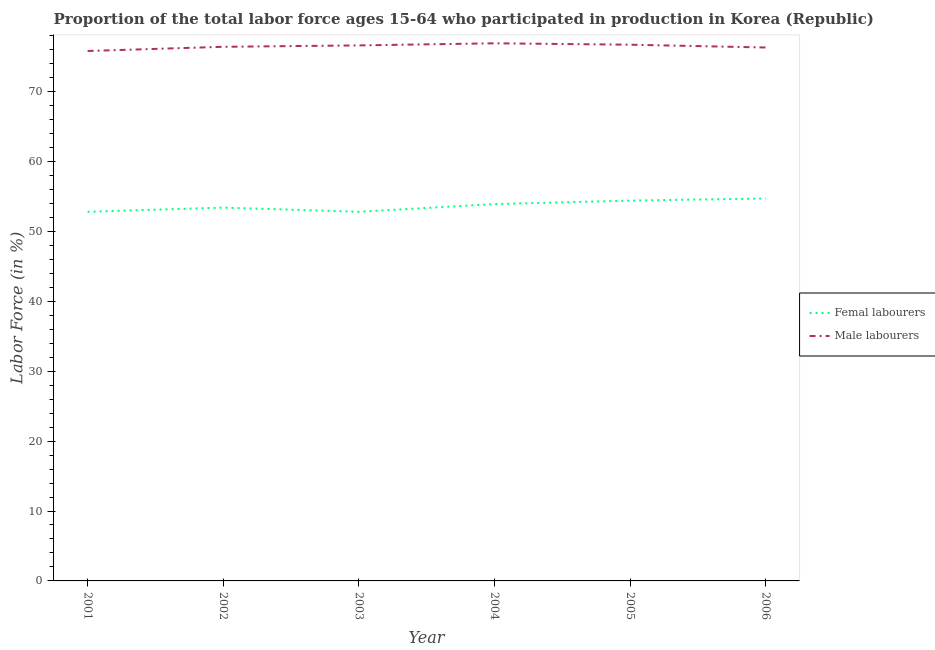How many different coloured lines are there?
Make the answer very short. 2. Does the line corresponding to percentage of male labour force intersect with the line corresponding to percentage of female labor force?
Your response must be concise. No. Is the number of lines equal to the number of legend labels?
Offer a terse response. Yes. What is the percentage of female labor force in 2005?
Ensure brevity in your answer.  54.4. Across all years, what is the maximum percentage of male labour force?
Your response must be concise. 76.9. Across all years, what is the minimum percentage of male labour force?
Provide a succinct answer. 75.8. What is the total percentage of female labor force in the graph?
Your response must be concise. 322. What is the difference between the percentage of female labor force in 2001 and that in 2005?
Your answer should be very brief. -1.6. What is the difference between the percentage of male labour force in 2006 and the percentage of female labor force in 2002?
Give a very brief answer. 22.9. What is the average percentage of male labour force per year?
Provide a short and direct response. 76.45. In the year 2006, what is the difference between the percentage of male labour force and percentage of female labor force?
Your response must be concise. 21.6. In how many years, is the percentage of female labor force greater than 68 %?
Provide a short and direct response. 0. What is the ratio of the percentage of male labour force in 2001 to that in 2006?
Provide a short and direct response. 0.99. Is the difference between the percentage of female labor force in 2003 and 2005 greater than the difference between the percentage of male labour force in 2003 and 2005?
Your response must be concise. No. What is the difference between the highest and the second highest percentage of female labor force?
Offer a very short reply. 0.3. What is the difference between the highest and the lowest percentage of female labor force?
Give a very brief answer. 1.9. Does the percentage of male labour force monotonically increase over the years?
Give a very brief answer. No. Is the percentage of female labor force strictly greater than the percentage of male labour force over the years?
Ensure brevity in your answer.  No. Is the percentage of male labour force strictly less than the percentage of female labor force over the years?
Keep it short and to the point. No. What is the difference between two consecutive major ticks on the Y-axis?
Offer a terse response. 10. Are the values on the major ticks of Y-axis written in scientific E-notation?
Keep it short and to the point. No. Does the graph contain any zero values?
Make the answer very short. No. How many legend labels are there?
Your answer should be compact. 2. How are the legend labels stacked?
Offer a terse response. Vertical. What is the title of the graph?
Offer a very short reply. Proportion of the total labor force ages 15-64 who participated in production in Korea (Republic). Does "Personal remittances" appear as one of the legend labels in the graph?
Ensure brevity in your answer.  No. What is the label or title of the X-axis?
Keep it short and to the point. Year. What is the Labor Force (in %) in Femal labourers in 2001?
Keep it short and to the point. 52.8. What is the Labor Force (in %) of Male labourers in 2001?
Ensure brevity in your answer.  75.8. What is the Labor Force (in %) of Femal labourers in 2002?
Your answer should be compact. 53.4. What is the Labor Force (in %) in Male labourers in 2002?
Offer a terse response. 76.4. What is the Labor Force (in %) of Femal labourers in 2003?
Give a very brief answer. 52.8. What is the Labor Force (in %) in Male labourers in 2003?
Keep it short and to the point. 76.6. What is the Labor Force (in %) in Femal labourers in 2004?
Provide a succinct answer. 53.9. What is the Labor Force (in %) in Male labourers in 2004?
Offer a terse response. 76.9. What is the Labor Force (in %) in Femal labourers in 2005?
Your answer should be very brief. 54.4. What is the Labor Force (in %) in Male labourers in 2005?
Ensure brevity in your answer.  76.7. What is the Labor Force (in %) in Femal labourers in 2006?
Offer a very short reply. 54.7. What is the Labor Force (in %) of Male labourers in 2006?
Your response must be concise. 76.3. Across all years, what is the maximum Labor Force (in %) in Femal labourers?
Offer a terse response. 54.7. Across all years, what is the maximum Labor Force (in %) of Male labourers?
Your answer should be compact. 76.9. Across all years, what is the minimum Labor Force (in %) of Femal labourers?
Your answer should be very brief. 52.8. Across all years, what is the minimum Labor Force (in %) of Male labourers?
Keep it short and to the point. 75.8. What is the total Labor Force (in %) in Femal labourers in the graph?
Keep it short and to the point. 322. What is the total Labor Force (in %) of Male labourers in the graph?
Your answer should be compact. 458.7. What is the difference between the Labor Force (in %) in Femal labourers in 2001 and that in 2002?
Make the answer very short. -0.6. What is the difference between the Labor Force (in %) of Femal labourers in 2001 and that in 2003?
Offer a very short reply. 0. What is the difference between the Labor Force (in %) of Male labourers in 2001 and that in 2004?
Your answer should be compact. -1.1. What is the difference between the Labor Force (in %) in Male labourers in 2001 and that in 2005?
Provide a succinct answer. -0.9. What is the difference between the Labor Force (in %) of Femal labourers in 2002 and that in 2003?
Make the answer very short. 0.6. What is the difference between the Labor Force (in %) of Femal labourers in 2002 and that in 2004?
Provide a succinct answer. -0.5. What is the difference between the Labor Force (in %) of Male labourers in 2002 and that in 2005?
Ensure brevity in your answer.  -0.3. What is the difference between the Labor Force (in %) in Femal labourers in 2002 and that in 2006?
Your answer should be compact. -1.3. What is the difference between the Labor Force (in %) in Femal labourers in 2003 and that in 2006?
Your answer should be very brief. -1.9. What is the difference between the Labor Force (in %) of Male labourers in 2004 and that in 2006?
Make the answer very short. 0.6. What is the difference between the Labor Force (in %) of Femal labourers in 2005 and that in 2006?
Keep it short and to the point. -0.3. What is the difference between the Labor Force (in %) of Femal labourers in 2001 and the Labor Force (in %) of Male labourers in 2002?
Offer a terse response. -23.6. What is the difference between the Labor Force (in %) of Femal labourers in 2001 and the Labor Force (in %) of Male labourers in 2003?
Your answer should be compact. -23.8. What is the difference between the Labor Force (in %) in Femal labourers in 2001 and the Labor Force (in %) in Male labourers in 2004?
Your answer should be very brief. -24.1. What is the difference between the Labor Force (in %) of Femal labourers in 2001 and the Labor Force (in %) of Male labourers in 2005?
Your response must be concise. -23.9. What is the difference between the Labor Force (in %) of Femal labourers in 2001 and the Labor Force (in %) of Male labourers in 2006?
Offer a very short reply. -23.5. What is the difference between the Labor Force (in %) in Femal labourers in 2002 and the Labor Force (in %) in Male labourers in 2003?
Make the answer very short. -23.2. What is the difference between the Labor Force (in %) in Femal labourers in 2002 and the Labor Force (in %) in Male labourers in 2004?
Your answer should be very brief. -23.5. What is the difference between the Labor Force (in %) of Femal labourers in 2002 and the Labor Force (in %) of Male labourers in 2005?
Offer a very short reply. -23.3. What is the difference between the Labor Force (in %) in Femal labourers in 2002 and the Labor Force (in %) in Male labourers in 2006?
Keep it short and to the point. -22.9. What is the difference between the Labor Force (in %) in Femal labourers in 2003 and the Labor Force (in %) in Male labourers in 2004?
Ensure brevity in your answer.  -24.1. What is the difference between the Labor Force (in %) of Femal labourers in 2003 and the Labor Force (in %) of Male labourers in 2005?
Keep it short and to the point. -23.9. What is the difference between the Labor Force (in %) of Femal labourers in 2003 and the Labor Force (in %) of Male labourers in 2006?
Provide a succinct answer. -23.5. What is the difference between the Labor Force (in %) of Femal labourers in 2004 and the Labor Force (in %) of Male labourers in 2005?
Your answer should be compact. -22.8. What is the difference between the Labor Force (in %) of Femal labourers in 2004 and the Labor Force (in %) of Male labourers in 2006?
Offer a very short reply. -22.4. What is the difference between the Labor Force (in %) of Femal labourers in 2005 and the Labor Force (in %) of Male labourers in 2006?
Your answer should be very brief. -21.9. What is the average Labor Force (in %) of Femal labourers per year?
Offer a terse response. 53.67. What is the average Labor Force (in %) of Male labourers per year?
Give a very brief answer. 76.45. In the year 2003, what is the difference between the Labor Force (in %) of Femal labourers and Labor Force (in %) of Male labourers?
Offer a very short reply. -23.8. In the year 2005, what is the difference between the Labor Force (in %) of Femal labourers and Labor Force (in %) of Male labourers?
Your answer should be compact. -22.3. In the year 2006, what is the difference between the Labor Force (in %) of Femal labourers and Labor Force (in %) of Male labourers?
Offer a very short reply. -21.6. What is the ratio of the Labor Force (in %) of Femal labourers in 2001 to that in 2002?
Make the answer very short. 0.99. What is the ratio of the Labor Force (in %) of Male labourers in 2001 to that in 2002?
Give a very brief answer. 0.99. What is the ratio of the Labor Force (in %) of Male labourers in 2001 to that in 2003?
Provide a short and direct response. 0.99. What is the ratio of the Labor Force (in %) in Femal labourers in 2001 to that in 2004?
Provide a succinct answer. 0.98. What is the ratio of the Labor Force (in %) in Male labourers in 2001 to that in 2004?
Your answer should be very brief. 0.99. What is the ratio of the Labor Force (in %) in Femal labourers in 2001 to that in 2005?
Give a very brief answer. 0.97. What is the ratio of the Labor Force (in %) of Male labourers in 2001 to that in 2005?
Provide a short and direct response. 0.99. What is the ratio of the Labor Force (in %) of Femal labourers in 2001 to that in 2006?
Provide a short and direct response. 0.97. What is the ratio of the Labor Force (in %) of Femal labourers in 2002 to that in 2003?
Provide a succinct answer. 1.01. What is the ratio of the Labor Force (in %) of Male labourers in 2002 to that in 2004?
Offer a very short reply. 0.99. What is the ratio of the Labor Force (in %) in Femal labourers in 2002 to that in 2005?
Your answer should be compact. 0.98. What is the ratio of the Labor Force (in %) in Male labourers in 2002 to that in 2005?
Offer a terse response. 1. What is the ratio of the Labor Force (in %) in Femal labourers in 2002 to that in 2006?
Your answer should be very brief. 0.98. What is the ratio of the Labor Force (in %) in Male labourers in 2002 to that in 2006?
Offer a very short reply. 1. What is the ratio of the Labor Force (in %) of Femal labourers in 2003 to that in 2004?
Make the answer very short. 0.98. What is the ratio of the Labor Force (in %) in Male labourers in 2003 to that in 2004?
Provide a short and direct response. 1. What is the ratio of the Labor Force (in %) in Femal labourers in 2003 to that in 2005?
Ensure brevity in your answer.  0.97. What is the ratio of the Labor Force (in %) of Male labourers in 2003 to that in 2005?
Make the answer very short. 1. What is the ratio of the Labor Force (in %) in Femal labourers in 2003 to that in 2006?
Offer a very short reply. 0.97. What is the ratio of the Labor Force (in %) of Femal labourers in 2004 to that in 2005?
Offer a very short reply. 0.99. What is the ratio of the Labor Force (in %) of Femal labourers in 2004 to that in 2006?
Your answer should be very brief. 0.99. What is the ratio of the Labor Force (in %) in Male labourers in 2004 to that in 2006?
Your response must be concise. 1.01. What is the ratio of the Labor Force (in %) in Femal labourers in 2005 to that in 2006?
Give a very brief answer. 0.99. What is the ratio of the Labor Force (in %) in Male labourers in 2005 to that in 2006?
Offer a terse response. 1.01. What is the difference between the highest and the second highest Labor Force (in %) of Femal labourers?
Make the answer very short. 0.3. What is the difference between the highest and the lowest Labor Force (in %) in Femal labourers?
Provide a succinct answer. 1.9. 